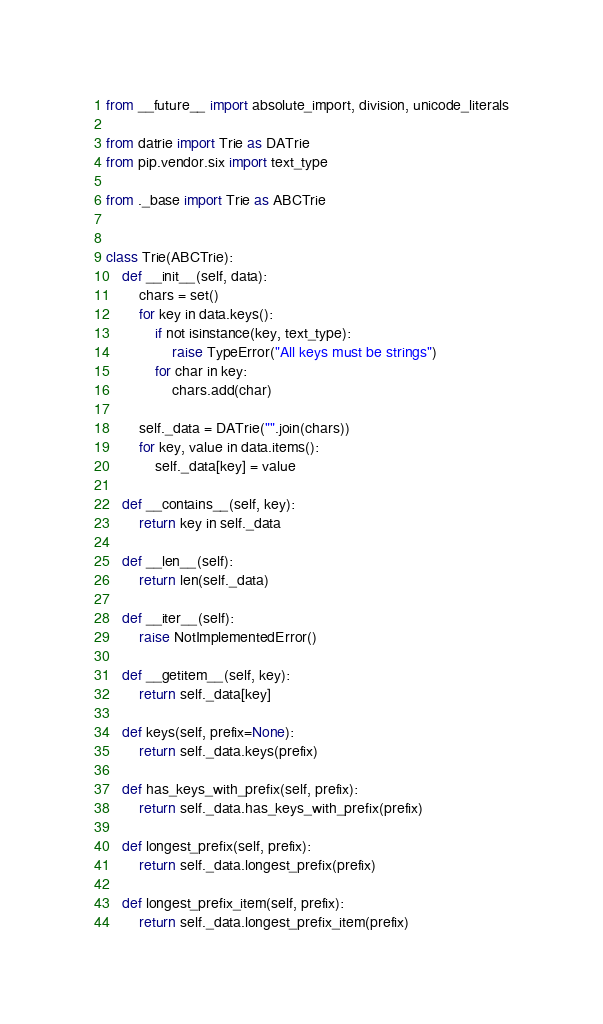<code> <loc_0><loc_0><loc_500><loc_500><_Python_>from __future__ import absolute_import, division, unicode_literals

from datrie import Trie as DATrie
from pip.vendor.six import text_type

from ._base import Trie as ABCTrie


class Trie(ABCTrie):
    def __init__(self, data):
        chars = set()
        for key in data.keys():
            if not isinstance(key, text_type):
                raise TypeError("All keys must be strings")
            for char in key:
                chars.add(char)

        self._data = DATrie("".join(chars))
        for key, value in data.items():
            self._data[key] = value

    def __contains__(self, key):
        return key in self._data

    def __len__(self):
        return len(self._data)

    def __iter__(self):
        raise NotImplementedError()

    def __getitem__(self, key):
        return self._data[key]

    def keys(self, prefix=None):
        return self._data.keys(prefix)

    def has_keys_with_prefix(self, prefix):
        return self._data.has_keys_with_prefix(prefix)

    def longest_prefix(self, prefix):
        return self._data.longest_prefix(prefix)

    def longest_prefix_item(self, prefix):
        return self._data.longest_prefix_item(prefix)
</code> 